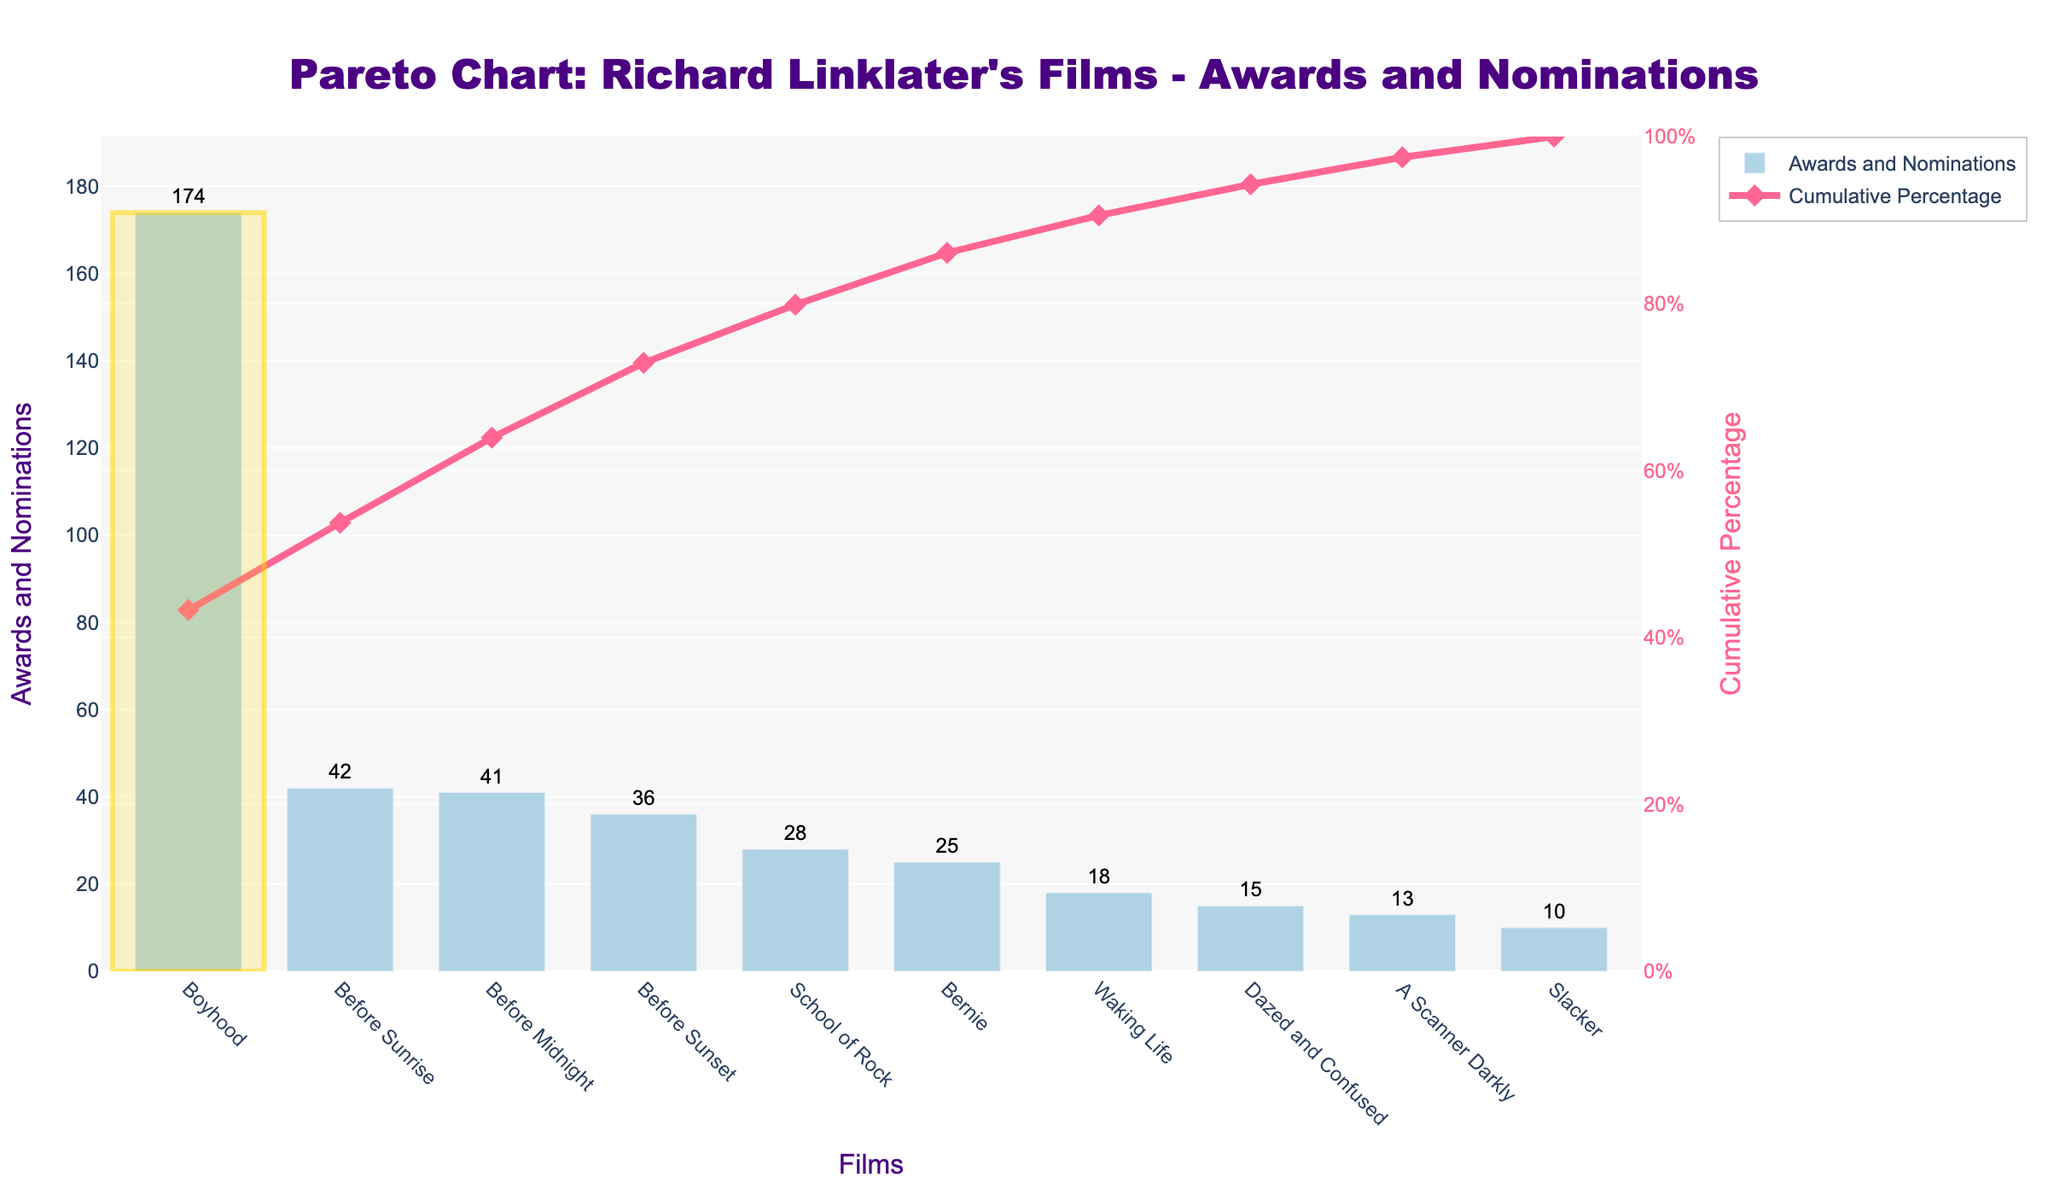How many films are listed in the figure? Count the number of distinct films on the x-axis.
Answer: 10 Which film has the highest number of awards and nominations? Identify the tallest bar in the figure, "Boyhood."
Answer: Boyhood What is the cumulative percentage of awards and nominations up to "Before Sunset"? Cumulative percentages add: Boyhood (174) + Before Sunrise (42) + Before Midnight (41) + Before Sunset (36). Total = 293/412 = ~71.12%.
Answer: ~71.12% How many awards and nominations does "School of Rock" have? Look at the bar height labeled "School of Rock" and its text value.
Answer: 28 What film has the lowest number of awards and nominations? Identify the shortest bar in the figure, which is "Slacker."
Answer: Slacker Compare the awards and nominations of "Dazed and Confused" and "Before Sunset". Which is higher and by how much? Compare the bar heights and text values of the two films: 36 (Before Sunset) - 15 (Dazed and Confused) = 21.
Answer: Before Sunset by 21 What is the approximate cumulative percentage for the first four most acclaimed films? Sum the top four values: Boyhood (174), Before Sunrise (42), Before Midnight (41), Before Sunset (36). Total = 293. 293/412 * 100 = ~71.12%.
Answer: ~71.12% How many films have more than 30 awards and nominations? Identify films with bars higher than 30 on the y-axis: Boyhood, Before Sunrise, Before Sunset, Before Midnight. Total = 4.
Answer: 4 What does the red line with diamond markers represent in the figure? Observe the legend, which says "Cumulative Percentage."
Answer: Cumulative Percentage 